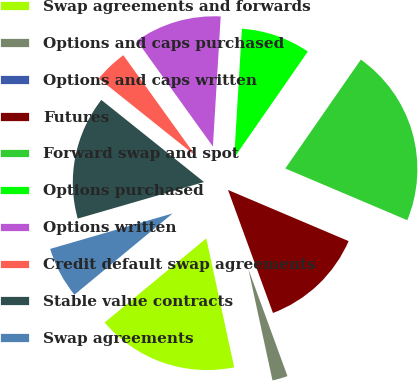Convert chart to OTSL. <chart><loc_0><loc_0><loc_500><loc_500><pie_chart><fcel>Swap agreements and forwards<fcel>Options and caps purchased<fcel>Options and caps written<fcel>Futures<fcel>Forward swap and spot<fcel>Options purchased<fcel>Options written<fcel>Credit default swap agreements<fcel>Stable value contracts<fcel>Swap agreements<nl><fcel>17.39%<fcel>2.18%<fcel>0.0%<fcel>13.04%<fcel>21.73%<fcel>8.7%<fcel>10.87%<fcel>4.35%<fcel>15.22%<fcel>6.52%<nl></chart> 